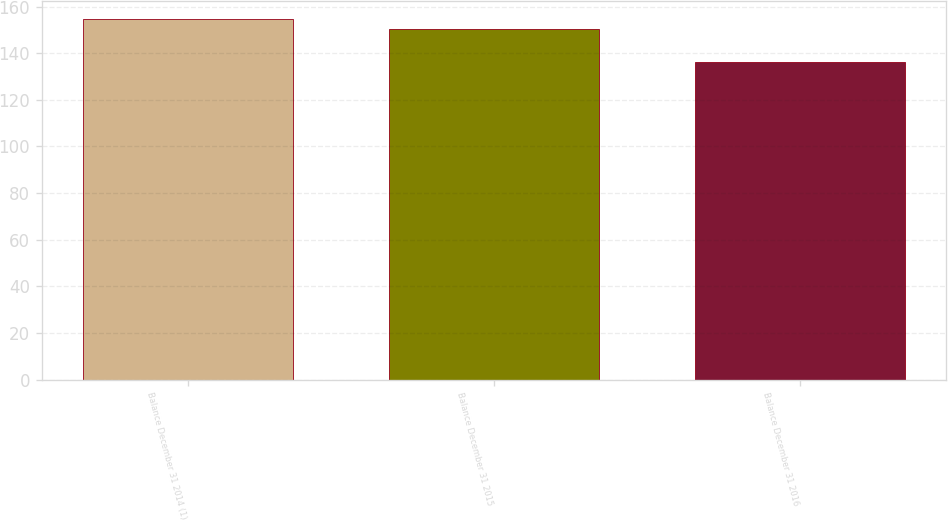<chart> <loc_0><loc_0><loc_500><loc_500><bar_chart><fcel>Balance December 31 2014 (1)<fcel>Balance December 31 2015<fcel>Balance December 31 2016<nl><fcel>154.8<fcel>150.6<fcel>136.3<nl></chart> 